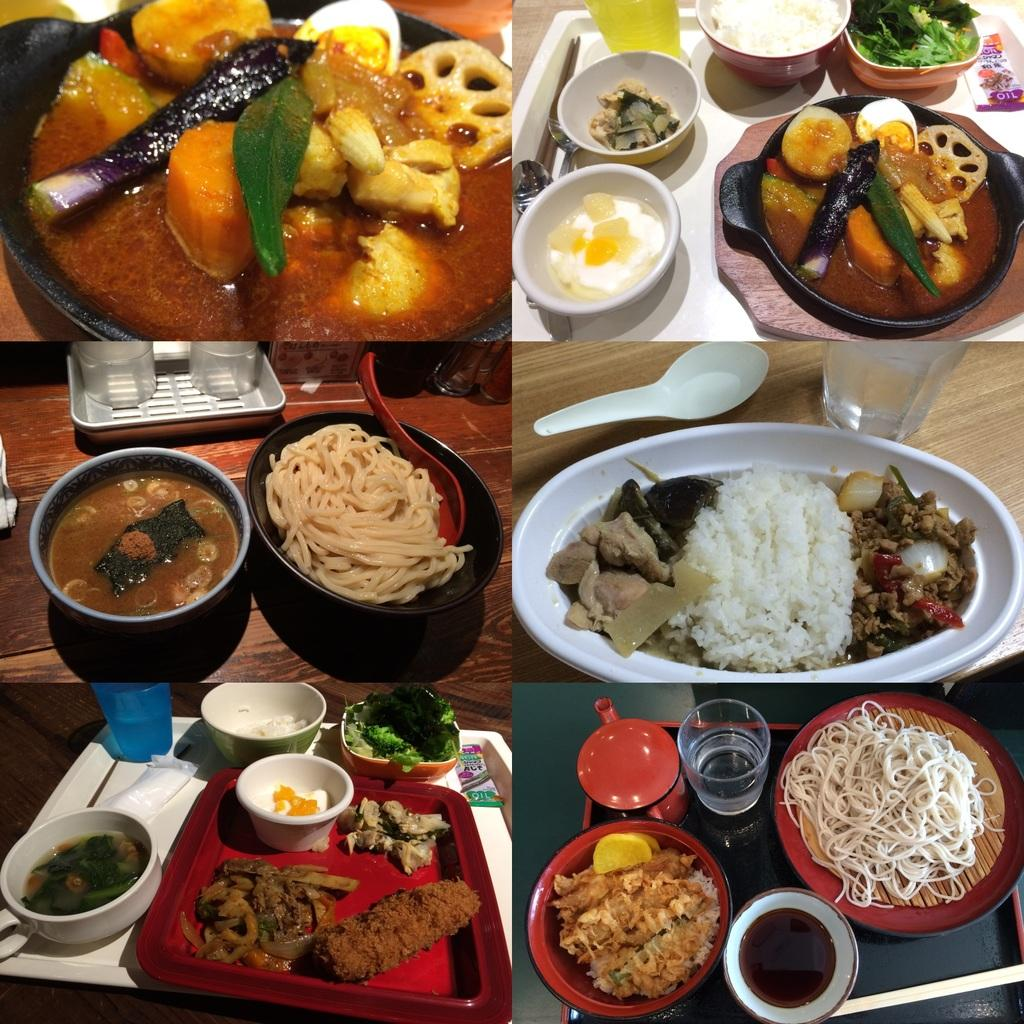What type of images are present in the collage? The collage contains photos of bowls, spoons, glasses, trays, and food items. What objects are commonly associated with eating or serving food? Bowls, spoons, glasses, and trays are commonly associated with eating or serving food. What can be found inside the bowls in the collage photos? The collage photos include food items in the bowls. How many tents are visible in the collage photos? There are no tents present in the collage photos; they contain images of bowls, spoons, glasses, trays, and food items. 